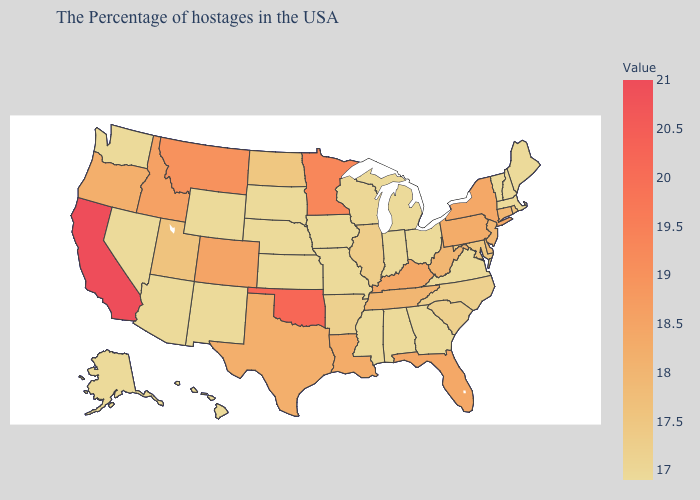Does California have the highest value in the West?
Concise answer only. Yes. Does California have the highest value in the USA?
Answer briefly. Yes. Among the states that border Nebraska , which have the highest value?
Give a very brief answer. Colorado. Is the legend a continuous bar?
Give a very brief answer. Yes. Among the states that border Maine , which have the lowest value?
Quick response, please. New Hampshire. Does the map have missing data?
Give a very brief answer. No. Does Alaska have the lowest value in the West?
Quick response, please. Yes. Among the states that border Utah , which have the lowest value?
Be succinct. Wyoming, New Mexico, Arizona, Nevada. 